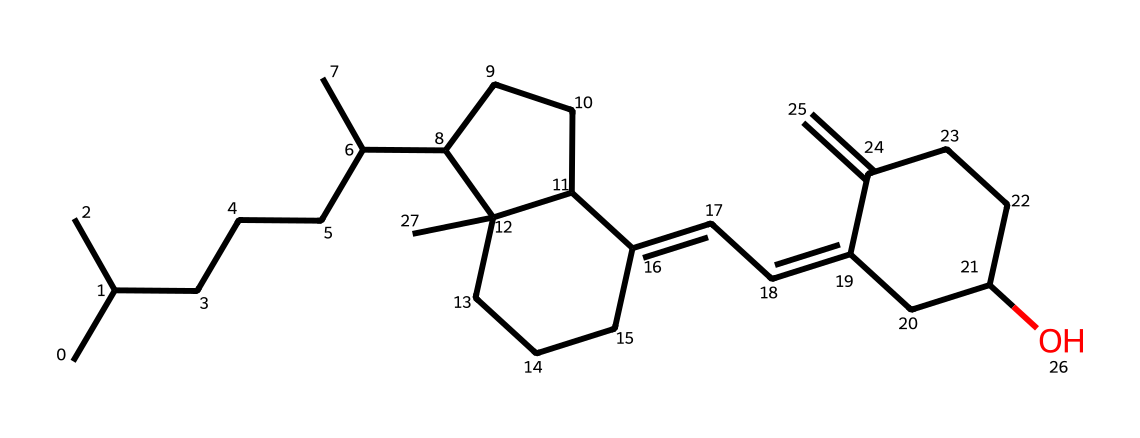What is the name of this vitamin? The vitamin represented in the SMILES structure is vitamin D, specifically cholecalciferol (D3), which is synthesized in the skin upon exposure to sunlight.
Answer: vitamin D How many carbon atoms are present in this structure? By analyzing the SMILES representation, I can count the carbon (C) atoms present. The total number of carbon atoms is 27.
Answer: 27 Does this structure contain any oxygen atoms? The SMILES notation indicates the presence of oxygen (O) atoms in the structure, specifically in the hydroxyl (-OH) group. There is one oxygen atom in this chemical.
Answer: 1 What type of chemical reaction forms vitamin D from cholesterol upon sunlight exposure? The reaction that synthesizes vitamin D from cholesterol involves ultraviolet (UV) radiation facilitating a photochemical reaction. This process is classified as a photochemical reaction.
Answer: photochemical What is the significance of the hydroxyl group in this vitamin? The presence of the hydroxyl (–OH) group in vitamin D is crucial for its biological function. It enhances the solubility in water and plays a role in the regulation of calcium metabolism in the body.
Answer: regulation of calcium metabolism What is the structural characteristic that indicates this is a steroid vitamin? The chemical structure contains multiple fused carbon rings, characteristic of steroid structure, which is evident in the arrangement of the cyclic portions of the molecule.
Answer: fused carbon rings Is this vitamin soluble in fats or water? Vitamin D, being a fat-soluble vitamin, dissolves in fats and oils rather than in water due to its hydrophobic nature derived from its molecular structure.
Answer: fats 